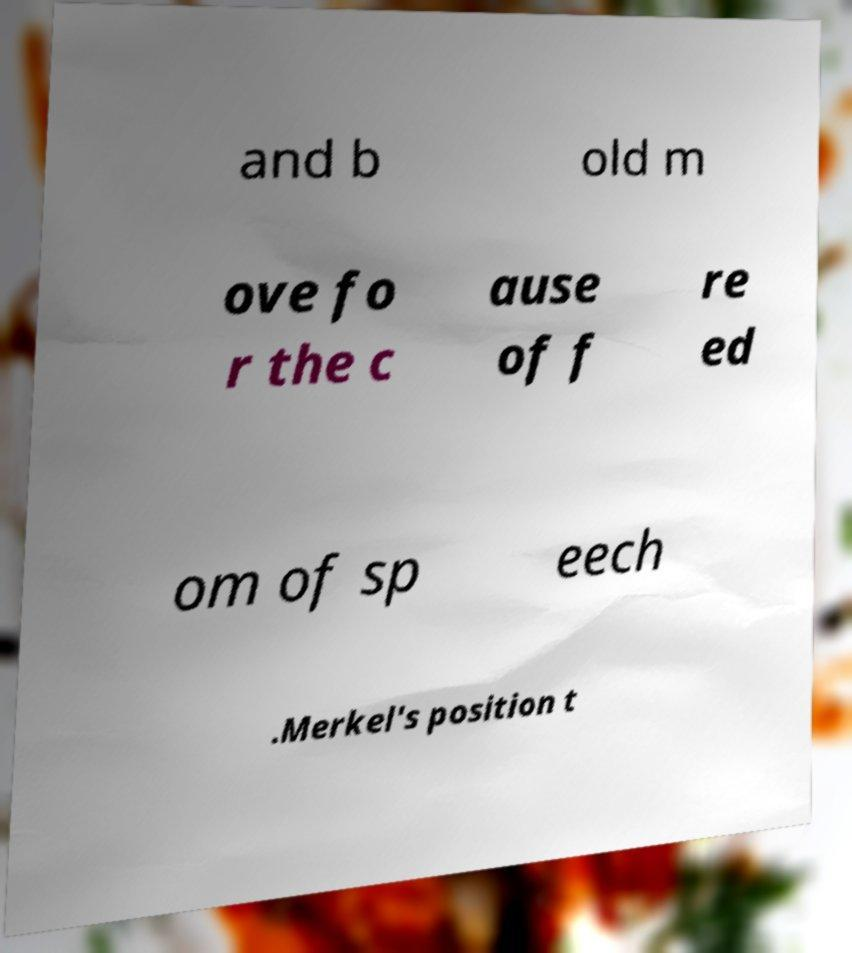Can you read and provide the text displayed in the image? This photo seems to have some interesting text. Can you extract and type it out for me? Certainly! The image displays a piece of paper with text that appears to be cut off and scrambled. It seems to have staggered lines that partially read: 'and b old m ove fo r the c ause of f re ed om of sp eech .Merkel's position t'. The text is incomplete, and some words are broken up, making it impossible to fully comprehend its message without additional context. 